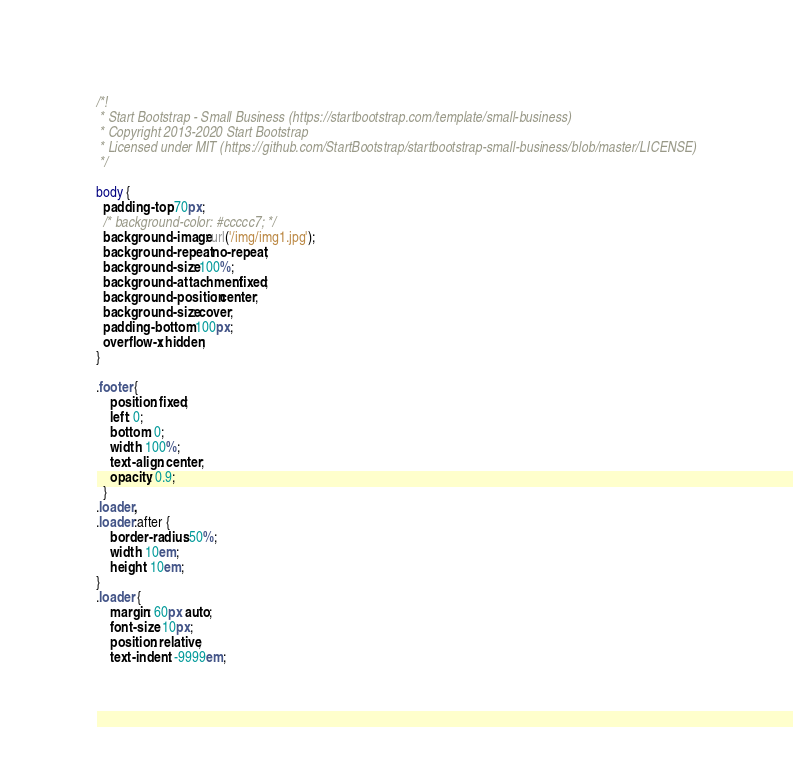<code> <loc_0><loc_0><loc_500><loc_500><_CSS_>/*!
 * Start Bootstrap - Small Business (https://startbootstrap.com/template/small-business)
 * Copyright 2013-2020 Start Bootstrap
 * Licensed under MIT (https://github.com/StartBootstrap/startbootstrap-small-business/blob/master/LICENSE)
 */

body {
  padding-top: 70px;
  /* background-color: #ccccc7; */
  background-image: url('/img/img1.jpg');
  background-repeat: no-repeat;
  background-size: 100%;
  background-attachment: fixed;
  background-position: center;
  background-size: cover;
  padding-bottom: 100px;
  overflow-x: hidden;
}

.footer {
    position: fixed;
    left: 0;
    bottom: 0;
    width: 100%;
    text-align: center;
    opacity: 0.9;
  }
.loader, 
.loader:after {
    border-radius: 50%;
    width: 10em;
    height: 10em;
}
.loader {
    margin: 60px auto;
    font-size: 10px;
    position: relative;
    text-indent: -9999em;</code> 